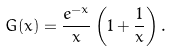Convert formula to latex. <formula><loc_0><loc_0><loc_500><loc_500>G ( x ) = \frac { e ^ { - x } } { x } \left ( 1 + \frac { 1 } { x } \right ) .</formula> 